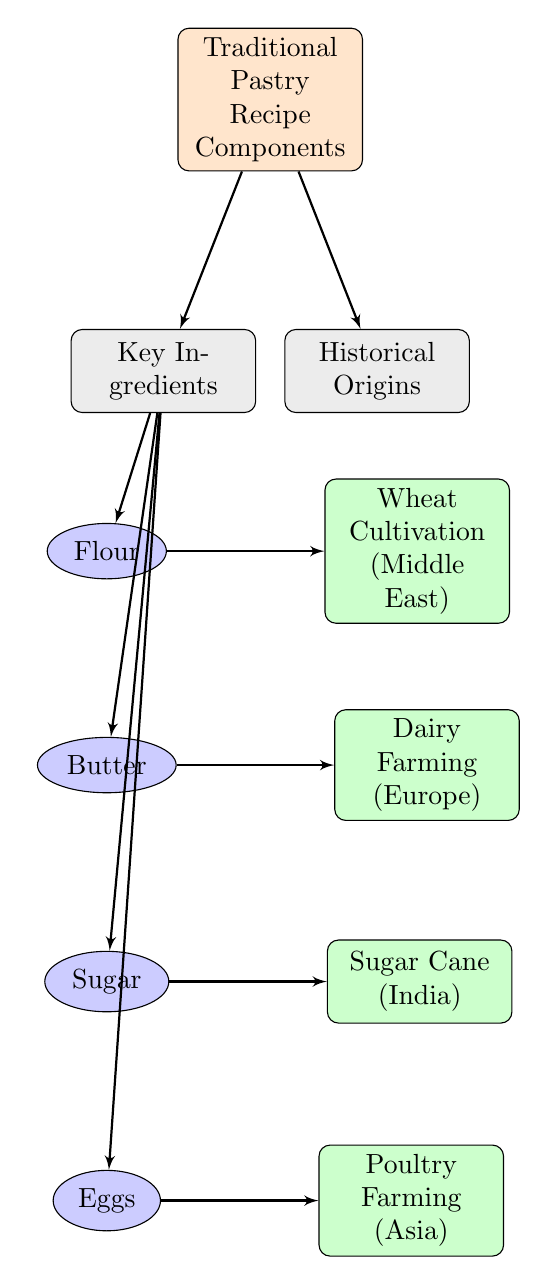What are the main components of a traditional pastry recipe? The main components are shown in the top node, labeled "Traditional Pastry Recipe Components", which connects to the key ingredients and historical origins.
Answer: Traditional Pastry Recipe Components How many key ingredients are listed in the diagram? There are four key ingredients listed under the "Key Ingredients" node: Flour, Butter, Sugar, and Eggs. This can be counted directly from the node.
Answer: 4 What ingredient is associated with wheat cultivation? The diagram shows that Flour is connected to Wheat Cultivation (Middle East), indicating that this ingredient has historical ties to wheat cultivation.
Answer: Flour Which historical origin is linked to sugar as an ingredient? The diagram connects Sugar to Sugar Cane (India), indicating that this ingredient's historical origin is from that region.
Answer: Sugar Cane (India) What does poultry farming relate to in this flow chart? The flow chart shows that Eggs are linked to Poultry Farming (Asia), which outlines the historical context of eggs as an ingredient in pastries.
Answer: Poultry Farming (Asia) Which ingredient in traditional pastries has dairy farming as its historical origin? Butter is connected in the diagram to Dairy Farming (Europe), which establishes this historical origin for the ingredient.
Answer: Butter What type of farming does eggs correlate with in the historical origins? The diagram indicates that Eggs correlate with Poultry Farming (Asia), establishing a link between the ingredient and its origin.
Answer: Poultry Farming (Asia) What is the relationship between sugar and its historical origin? Sugar is connected to Sugar Cane (India) in the diagram, which shows a direct relationship indicating where sugar historically originates.
Answer: Sugar Cane (India) 